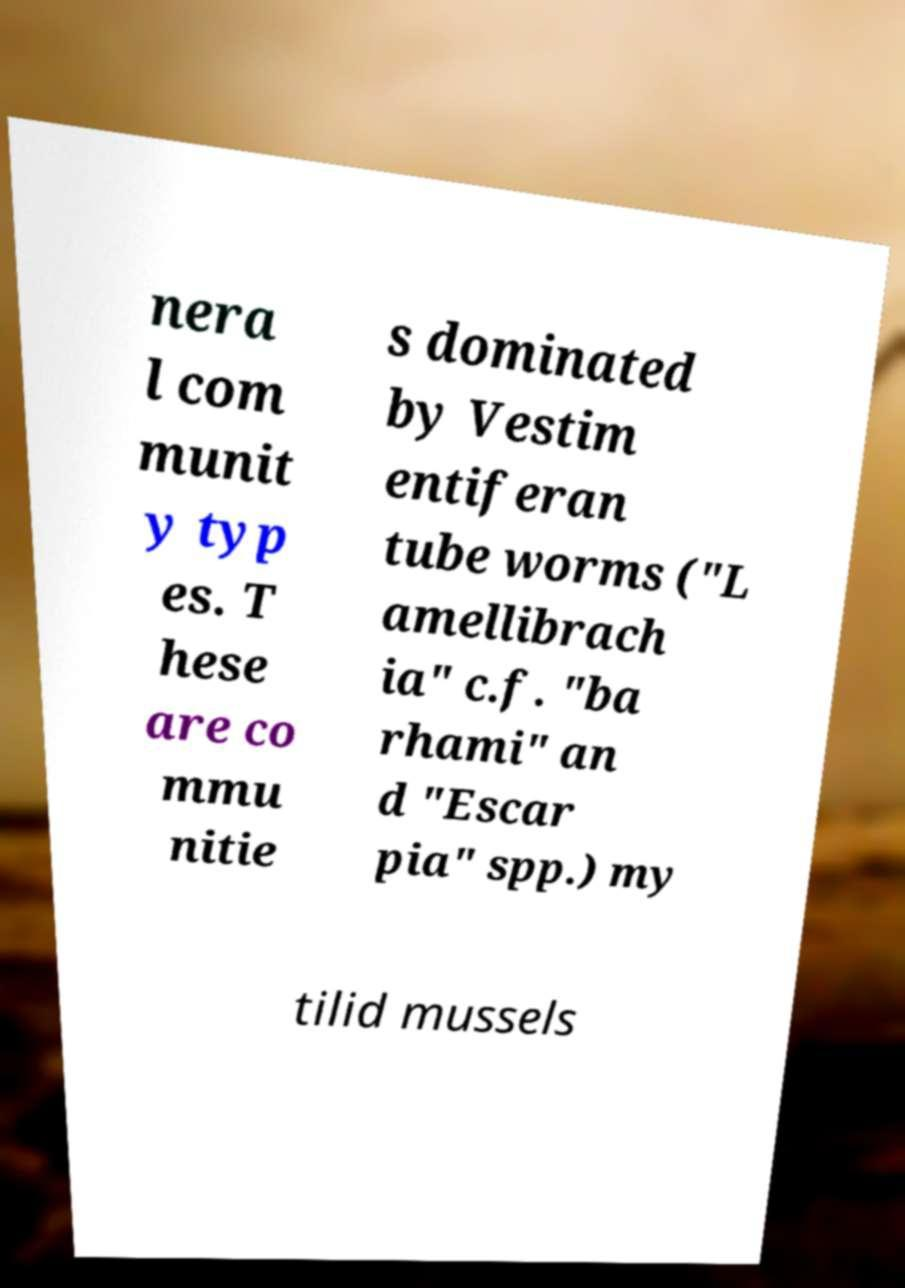There's text embedded in this image that I need extracted. Can you transcribe it verbatim? nera l com munit y typ es. T hese are co mmu nitie s dominated by Vestim entiferan tube worms ("L amellibrach ia" c.f. "ba rhami" an d "Escar pia" spp.) my tilid mussels 